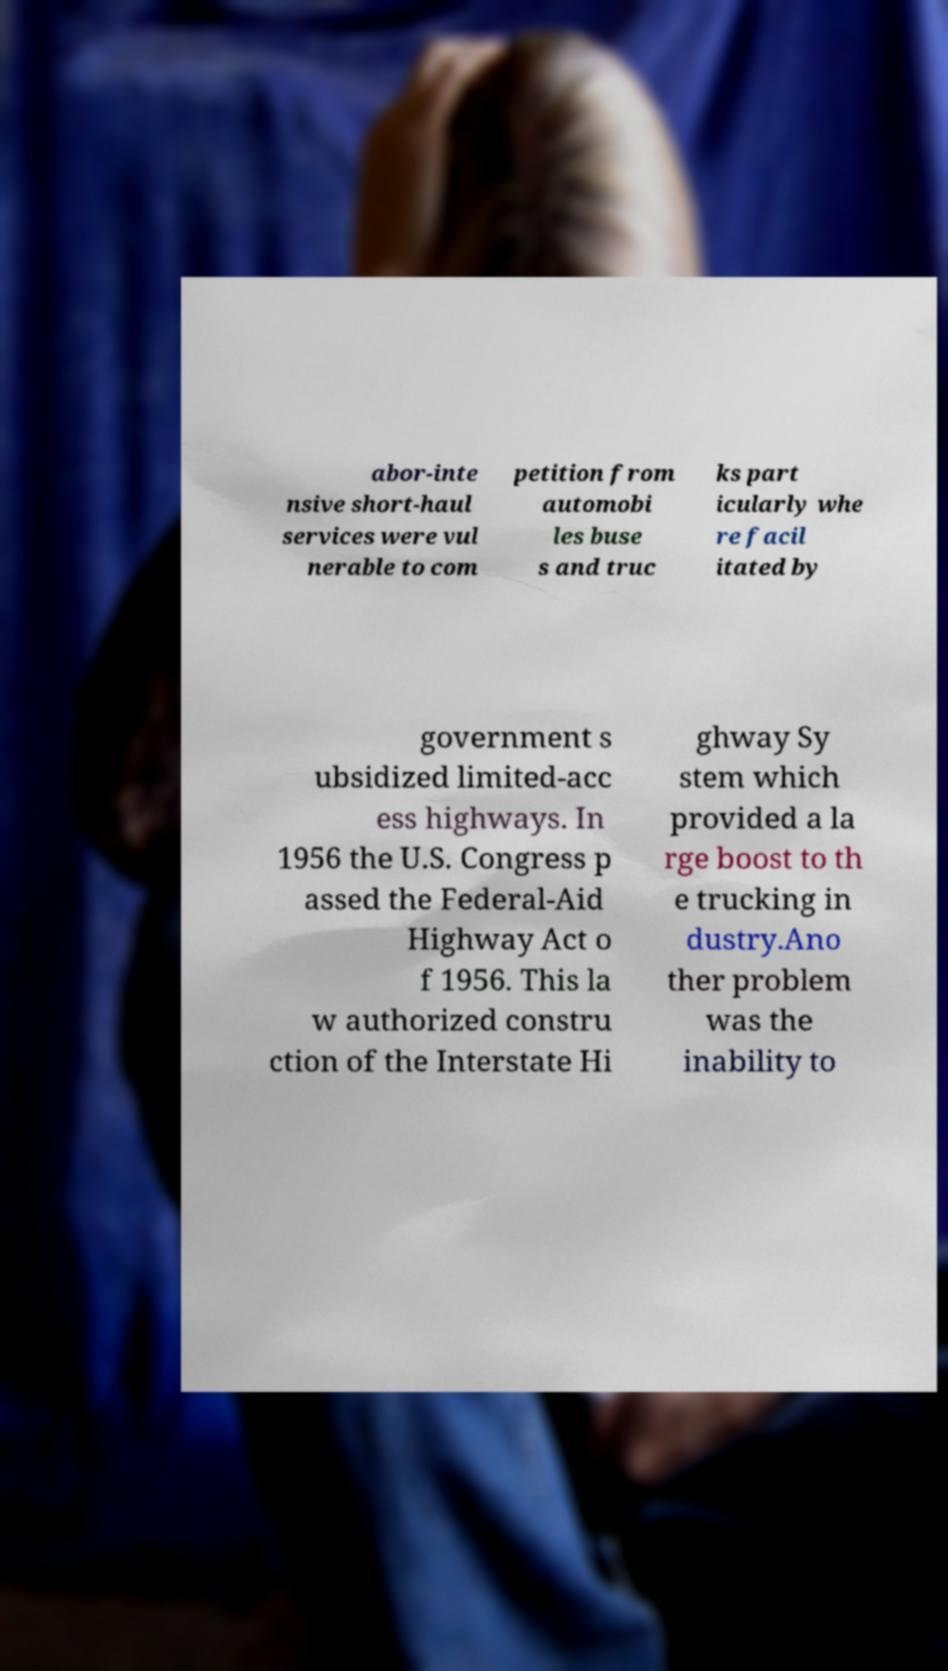Please identify and transcribe the text found in this image. abor-inte nsive short-haul services were vul nerable to com petition from automobi les buse s and truc ks part icularly whe re facil itated by government s ubsidized limited-acc ess highways. In 1956 the U.S. Congress p assed the Federal-Aid Highway Act o f 1956. This la w authorized constru ction of the Interstate Hi ghway Sy stem which provided a la rge boost to th e trucking in dustry.Ano ther problem was the inability to 